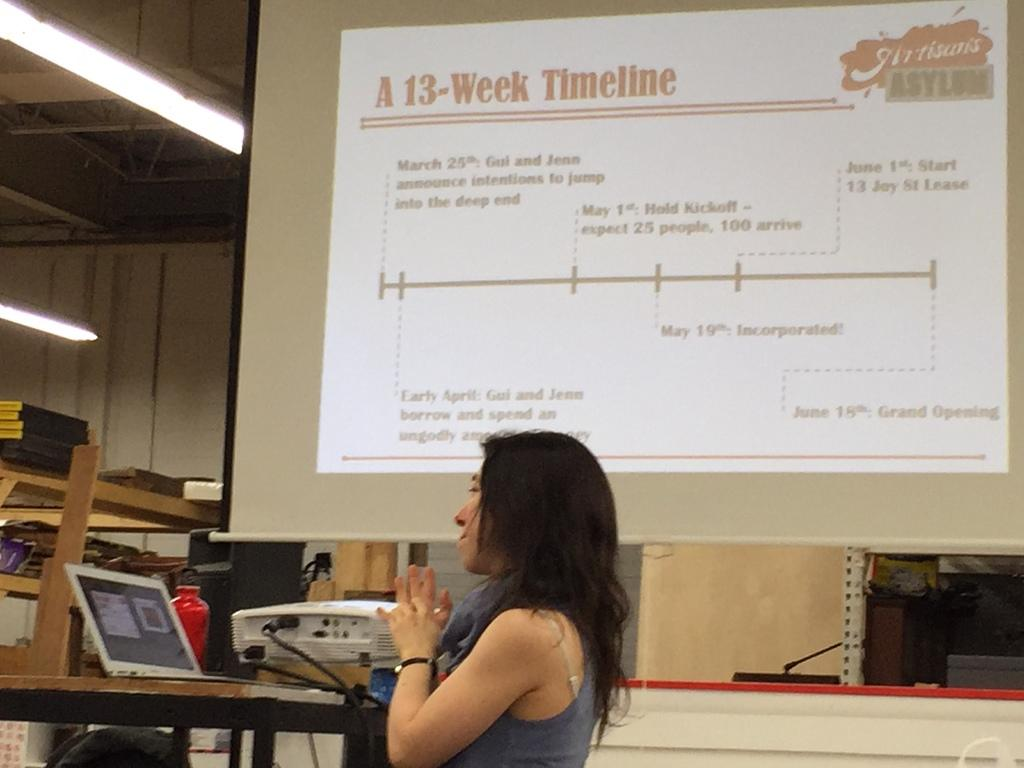What is the main subject of the image? There is a woman standing in the image. What objects can be seen in the background? There is a laptop, a projector, lights, and a projector screen in the background. What might the woman be doing in the image? It is possible that the woman is giving a presentation, as there is a projector and screen in the background. How many times has the woman folded the street in the image? There is no street present in the image, and folding a street is not possible. 